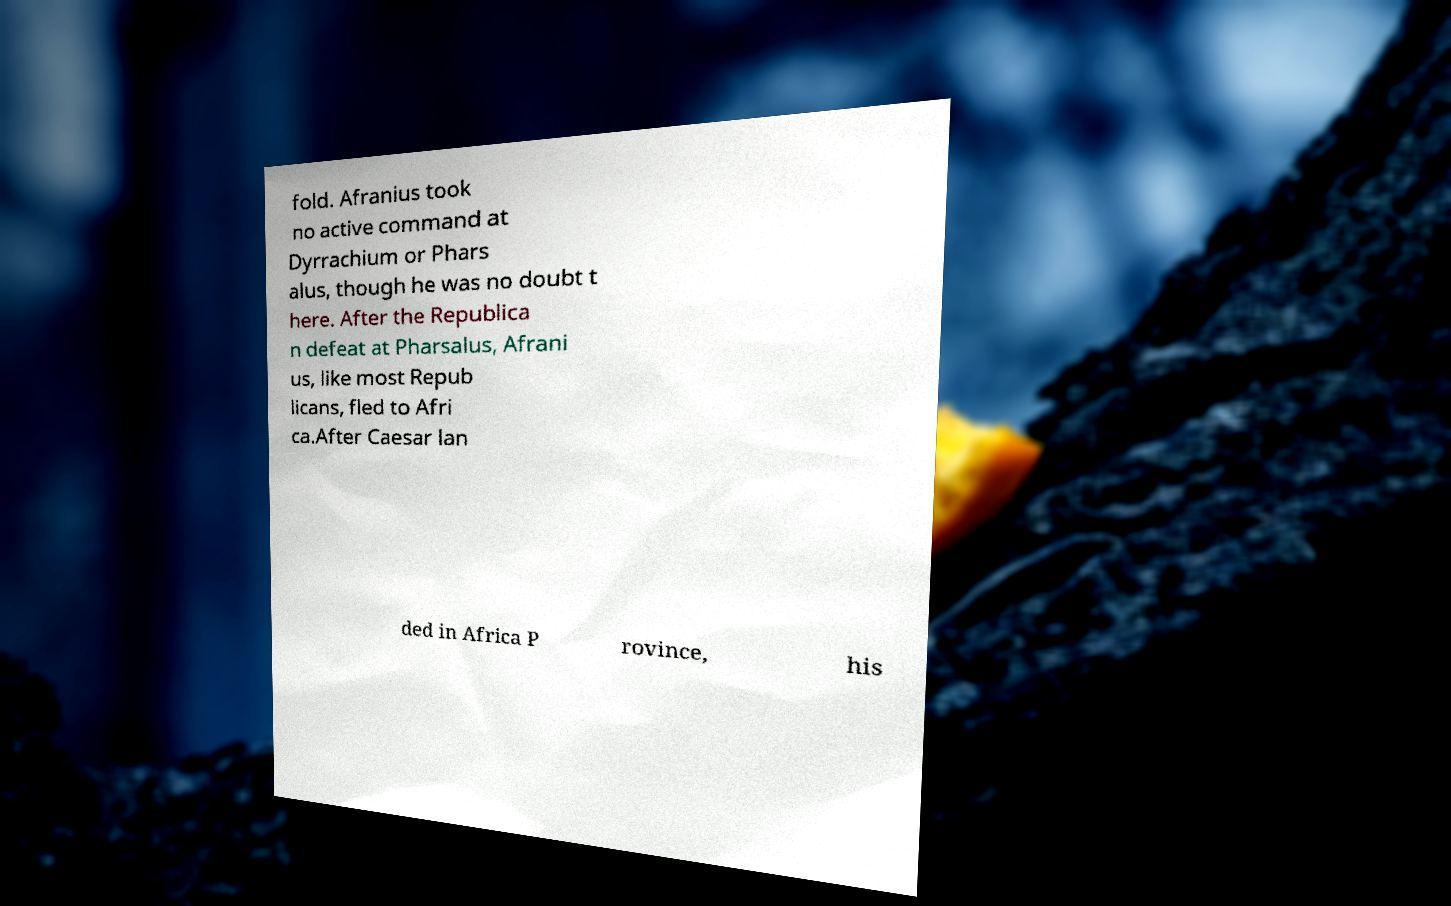What messages or text are displayed in this image? I need them in a readable, typed format. fold. Afranius took no active command at Dyrrachium or Phars alus, though he was no doubt t here. After the Republica n defeat at Pharsalus, Afrani us, like most Repub licans, fled to Afri ca.After Caesar lan ded in Africa P rovince, his 